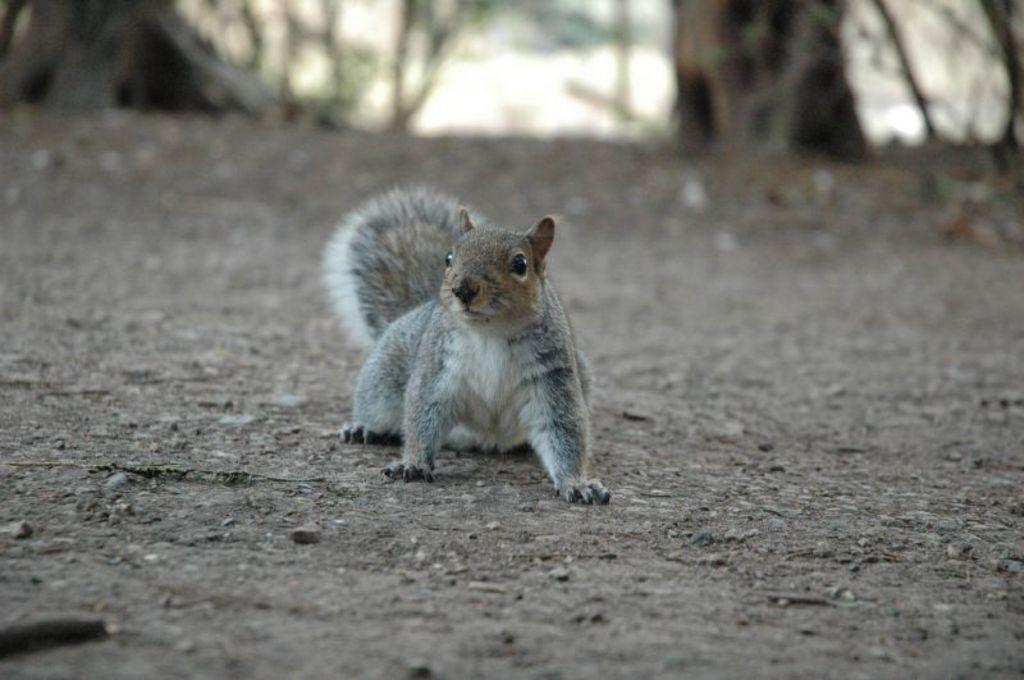What animal is in the foreground of the image? There is a squirrel in the foreground of the image. Where is the squirrel located? The squirrel is on the ground. What can be seen in the background of the image? There are trees visible in the background of the image. How many babies are being cared for by the maid in the image? There is no maid or babies present in the image; it features a squirrel on the ground with trees in the background. 